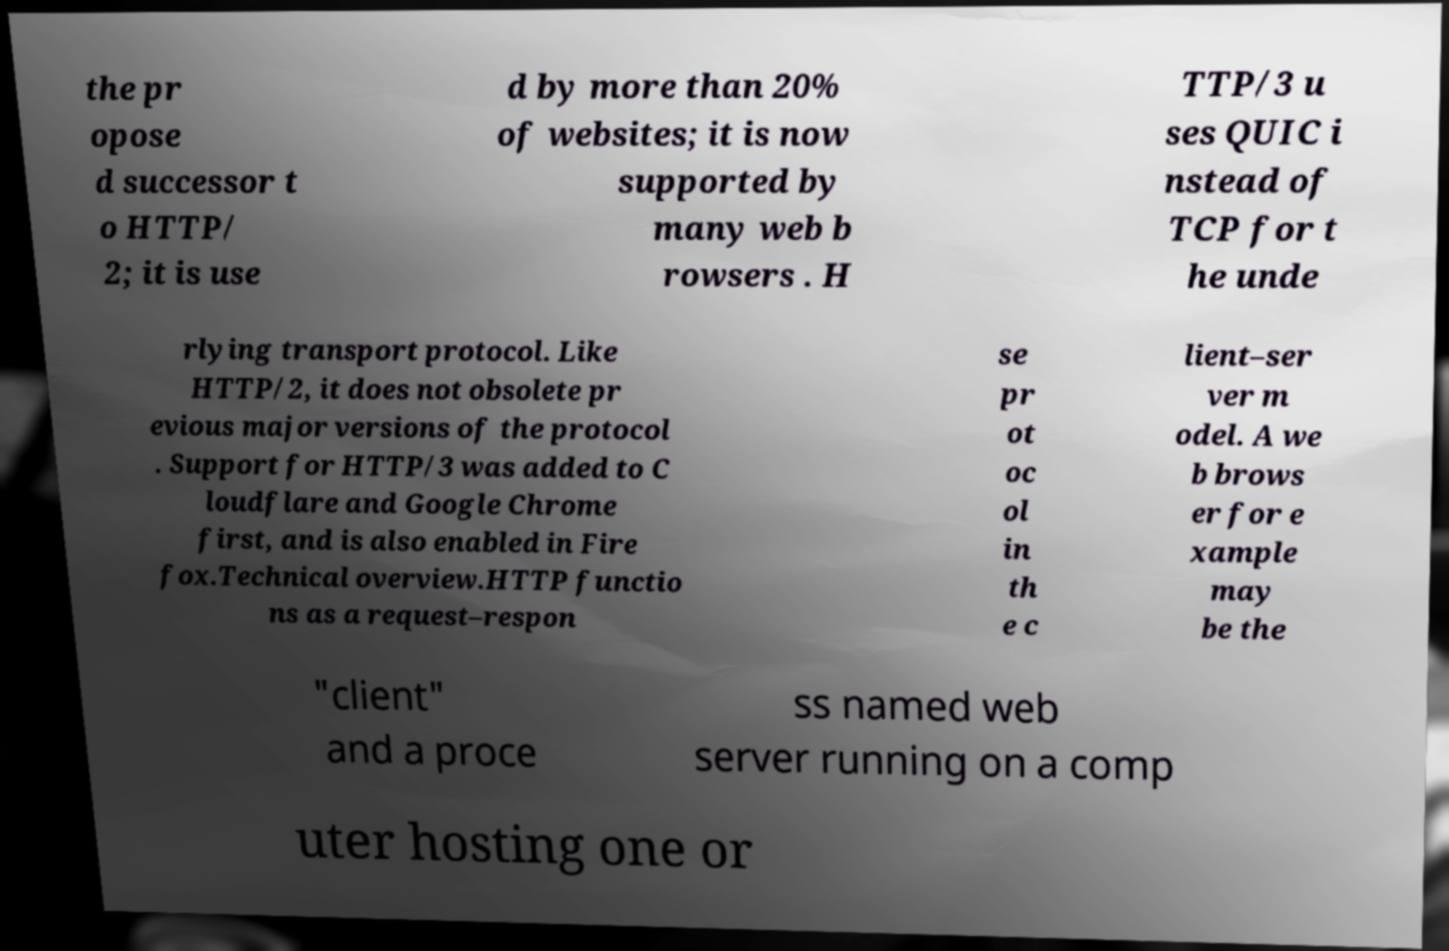Please read and relay the text visible in this image. What does it say? the pr opose d successor t o HTTP/ 2; it is use d by more than 20% of websites; it is now supported by many web b rowsers . H TTP/3 u ses QUIC i nstead of TCP for t he unde rlying transport protocol. Like HTTP/2, it does not obsolete pr evious major versions of the protocol . Support for HTTP/3 was added to C loudflare and Google Chrome first, and is also enabled in Fire fox.Technical overview.HTTP functio ns as a request–respon se pr ot oc ol in th e c lient–ser ver m odel. A we b brows er for e xample may be the "client" and a proce ss named web server running on a comp uter hosting one or 